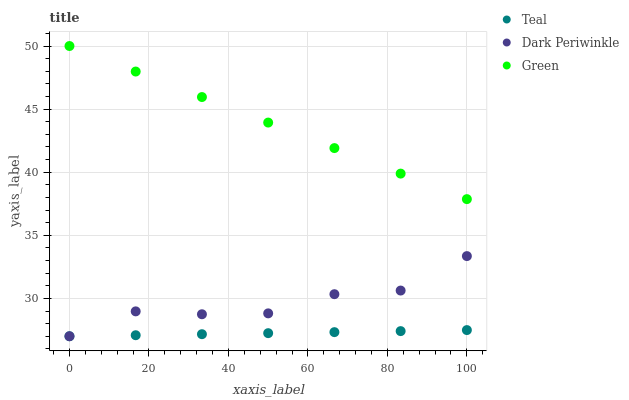Does Teal have the minimum area under the curve?
Answer yes or no. Yes. Does Green have the maximum area under the curve?
Answer yes or no. Yes. Does Dark Periwinkle have the minimum area under the curve?
Answer yes or no. No. Does Dark Periwinkle have the maximum area under the curve?
Answer yes or no. No. Is Teal the smoothest?
Answer yes or no. Yes. Is Dark Periwinkle the roughest?
Answer yes or no. Yes. Is Dark Periwinkle the smoothest?
Answer yes or no. No. Is Teal the roughest?
Answer yes or no. No. Does Dark Periwinkle have the lowest value?
Answer yes or no. Yes. Does Green have the highest value?
Answer yes or no. Yes. Does Dark Periwinkle have the highest value?
Answer yes or no. No. Is Teal less than Green?
Answer yes or no. Yes. Is Green greater than Teal?
Answer yes or no. Yes. Does Teal intersect Dark Periwinkle?
Answer yes or no. Yes. Is Teal less than Dark Periwinkle?
Answer yes or no. No. Is Teal greater than Dark Periwinkle?
Answer yes or no. No. Does Teal intersect Green?
Answer yes or no. No. 